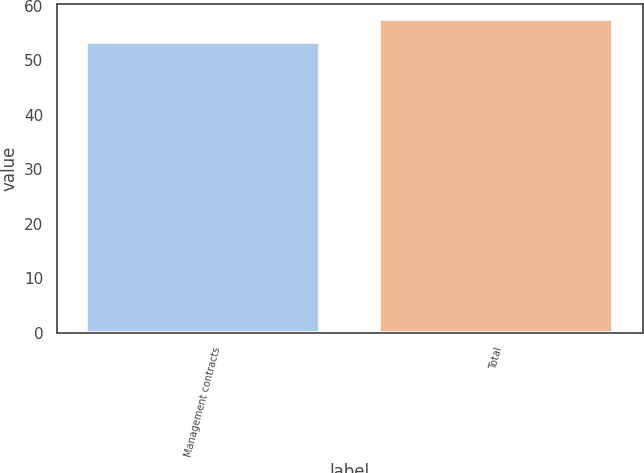Convert chart to OTSL. <chart><loc_0><loc_0><loc_500><loc_500><bar_chart><fcel>Management contracts<fcel>Total<nl><fcel>53.3<fcel>57.5<nl></chart> 